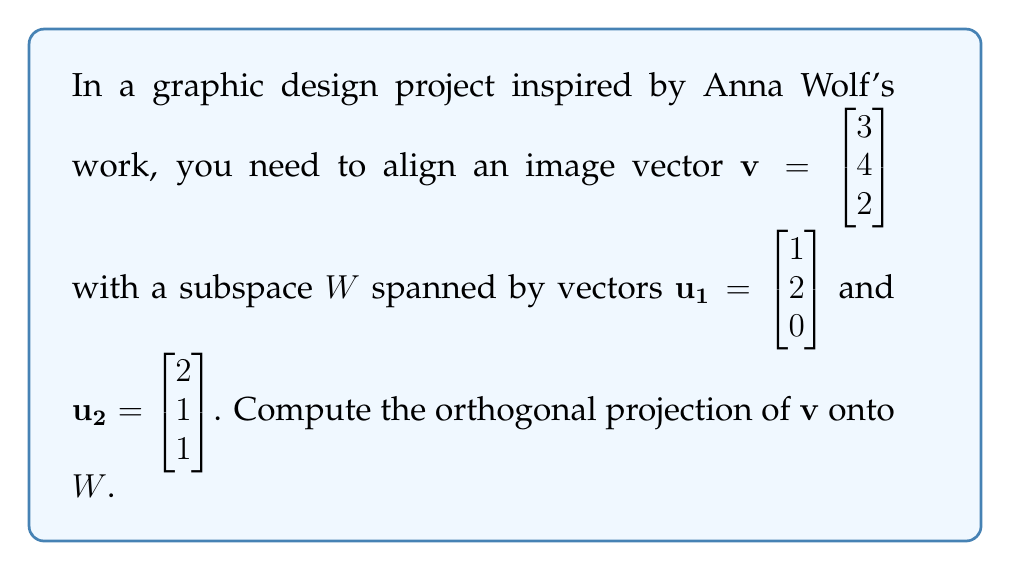Show me your answer to this math problem. To find the orthogonal projection of $\mathbf{v}$ onto $W$, we'll follow these steps:

1) First, we need to find an orthonormal basis for $W$. We'll use the Gram-Schmidt process:

   $\mathbf{e_1} = \frac{\mathbf{u_1}}{\|\mathbf{u_1}\|} = \frac{1}{\sqrt{5}}\begin{bmatrix} 1 \\ 2 \\ 0 \end{bmatrix}$

   $\mathbf{u_2'} = \mathbf{u_2} - (\mathbf{u_2} \cdot \mathbf{e_1})\mathbf{e_1} = \begin{bmatrix} 2 \\ 1 \\ 1 \end{bmatrix} - \frac{4}{\sqrt{5}}\begin{bmatrix} 1 \\ 2 \\ 0 \end{bmatrix} = \begin{bmatrix} 2-\frac{4}{\sqrt{5}} \\ 1-\frac{8}{\sqrt{5}} \\ 1 \end{bmatrix}$

   $\mathbf{e_2} = \frac{\mathbf{u_2'}}{\|\mathbf{u_2'}\|} = \frac{1}{\sqrt{6-\frac{24}{\sqrt{5}}+\frac{80}{5}}}\begin{bmatrix} 2-\frac{4}{\sqrt{5}} \\ 1-\frac{8}{\sqrt{5}} \\ 1 \end{bmatrix}$

2) Now, we can compute the projection using the formula:

   $\text{proj}_W(\mathbf{v}) = (\mathbf{v} \cdot \mathbf{e_1})\mathbf{e_1} + (\mathbf{v} \cdot \mathbf{e_2})\mathbf{e_2}$

3) Calculate the dot products:

   $\mathbf{v} \cdot \mathbf{e_1} = \frac{1}{\sqrt{5}}(3 + 8 + 0) = \frac{11}{\sqrt{5}}$

   $\mathbf{v} \cdot \mathbf{e_2} = \frac{1}{\sqrt{6-\frac{24}{\sqrt{5}}+\frac{80}{5}}}((3)(2-\frac{4}{\sqrt{5}}) + (4)(1-\frac{8}{\sqrt{5}}) + (2)(1))$

4) Substitute these values into the projection formula:

   $\text{proj}_W(\mathbf{v}) = \frac{11}{\sqrt{5}}\cdot\frac{1}{\sqrt{5}}\begin{bmatrix} 1 \\ 2 \\ 0 \end{bmatrix} + (\mathbf{v} \cdot \mathbf{e_2})\cdot\frac{1}{\sqrt{6-\frac{24}{\sqrt{5}}+\frac{80}{5}}}\begin{bmatrix} 2-\frac{4}{\sqrt{5}} \\ 1-\frac{8}{\sqrt{5}} \\ 1 \end{bmatrix}$

5) Simplify to get the final result.
Answer: $$\text{proj}_W(\mathbf{v}) = \begin{bmatrix} \frac{11}{5} \\ \frac{22}{5} \\ 0 \end{bmatrix} + (\mathbf{v} \cdot \mathbf{e_2})\cdot\frac{1}{6-\frac{24}{\sqrt{5}}+\frac{80}{5}}\begin{bmatrix} 2-\frac{4}{\sqrt{5}} \\ 1-\frac{8}{\sqrt{5}} \\ 1 \end{bmatrix}$$ 